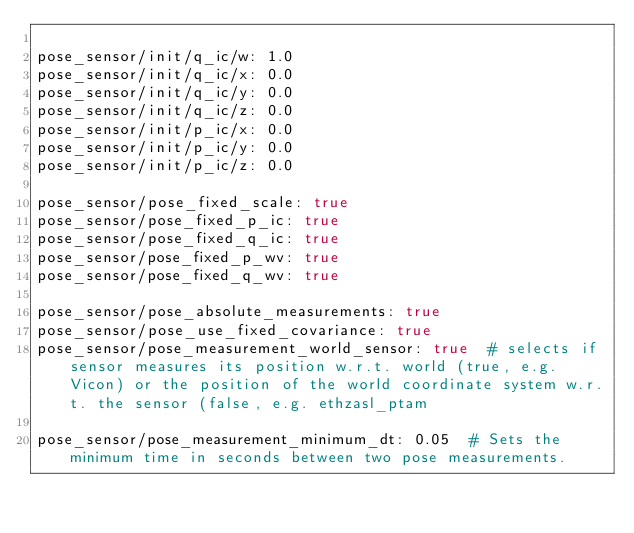<code> <loc_0><loc_0><loc_500><loc_500><_YAML_>
pose_sensor/init/q_ic/w: 1.0
pose_sensor/init/q_ic/x: 0.0
pose_sensor/init/q_ic/y: 0.0
pose_sensor/init/q_ic/z: 0.0
pose_sensor/init/p_ic/x: 0.0   
pose_sensor/init/p_ic/y: 0.0
pose_sensor/init/p_ic/z: 0.0

pose_sensor/pose_fixed_scale: true
pose_sensor/pose_fixed_p_ic: true
pose_sensor/pose_fixed_q_ic: true
pose_sensor/pose_fixed_p_wv: true
pose_sensor/pose_fixed_q_wv: true
 
pose_sensor/pose_absolute_measurements: true
pose_sensor/pose_use_fixed_covariance: true
pose_sensor/pose_measurement_world_sensor: true  # selects if sensor measures its position w.r.t. world (true, e.g. Vicon) or the position of the world coordinate system w.r.t. the sensor (false, e.g. ethzasl_ptam

pose_sensor/pose_measurement_minimum_dt: 0.05  # Sets the minimum time in seconds between two pose measurements.
</code> 